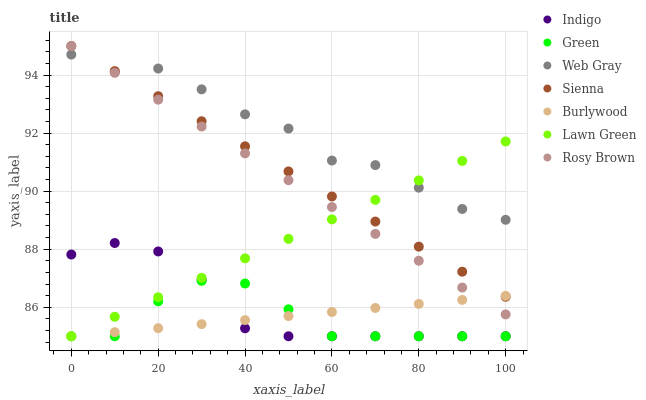Does Green have the minimum area under the curve?
Answer yes or no. Yes. Does Web Gray have the maximum area under the curve?
Answer yes or no. Yes. Does Indigo have the minimum area under the curve?
Answer yes or no. No. Does Indigo have the maximum area under the curve?
Answer yes or no. No. Is Burlywood the smoothest?
Answer yes or no. Yes. Is Web Gray the roughest?
Answer yes or no. Yes. Is Indigo the smoothest?
Answer yes or no. No. Is Indigo the roughest?
Answer yes or no. No. Does Lawn Green have the lowest value?
Answer yes or no. Yes. Does Web Gray have the lowest value?
Answer yes or no. No. Does Sienna have the highest value?
Answer yes or no. Yes. Does Web Gray have the highest value?
Answer yes or no. No. Is Green less than Web Gray?
Answer yes or no. Yes. Is Web Gray greater than Burlywood?
Answer yes or no. Yes. Does Lawn Green intersect Sienna?
Answer yes or no. Yes. Is Lawn Green less than Sienna?
Answer yes or no. No. Is Lawn Green greater than Sienna?
Answer yes or no. No. Does Green intersect Web Gray?
Answer yes or no. No. 